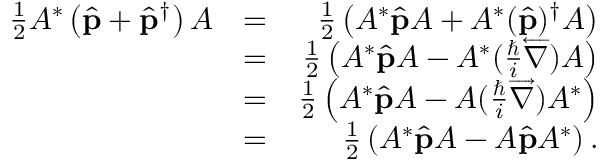Convert formula to latex. <formula><loc_0><loc_0><loc_500><loc_500>\begin{array} { r l r } { \frac { 1 } { 2 } A ^ { * } \left ( \hat { p } + \hat { p } ^ { \dagger } \right ) A } & { = } & { \frac { 1 } { 2 } \left ( A ^ { * } \hat { p } A + A ^ { * } ( \hat { p } ) ^ { \dagger } A \right ) } \\ & { = } & { \frac { 1 } { 2 } \left ( A ^ { * } \hat { p } A - A ^ { * } ( \frac { } { i } \overleftarrow { \nabla } ) A \right ) } \\ & { = } & { \frac { 1 } { 2 } \left ( A ^ { * } \hat { p } A - A ( \frac { } { i } \overrightarrow { \nabla } ) A ^ { * } \right ) } \\ & { = } & { \frac { 1 } { 2 } \left ( A ^ { * } \hat { p } A - A \hat { p } A ^ { * } \right ) . } \end{array}</formula> 